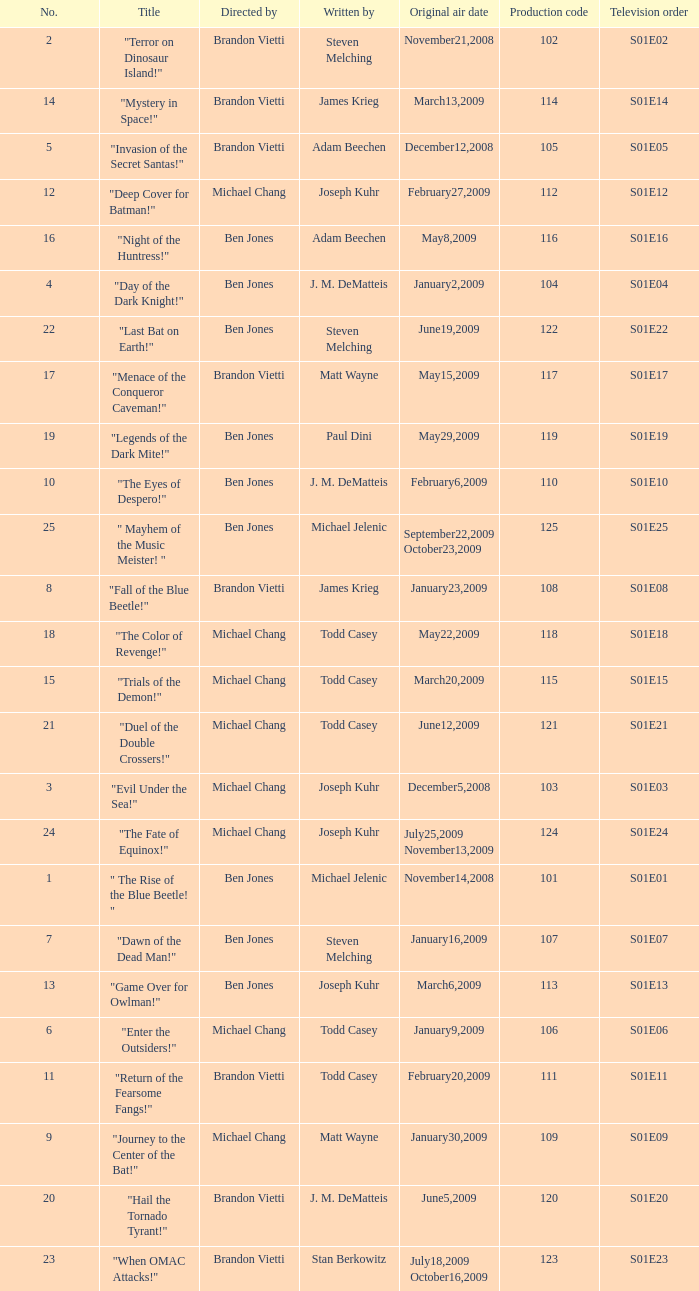Who directed s01e13 Ben Jones. 